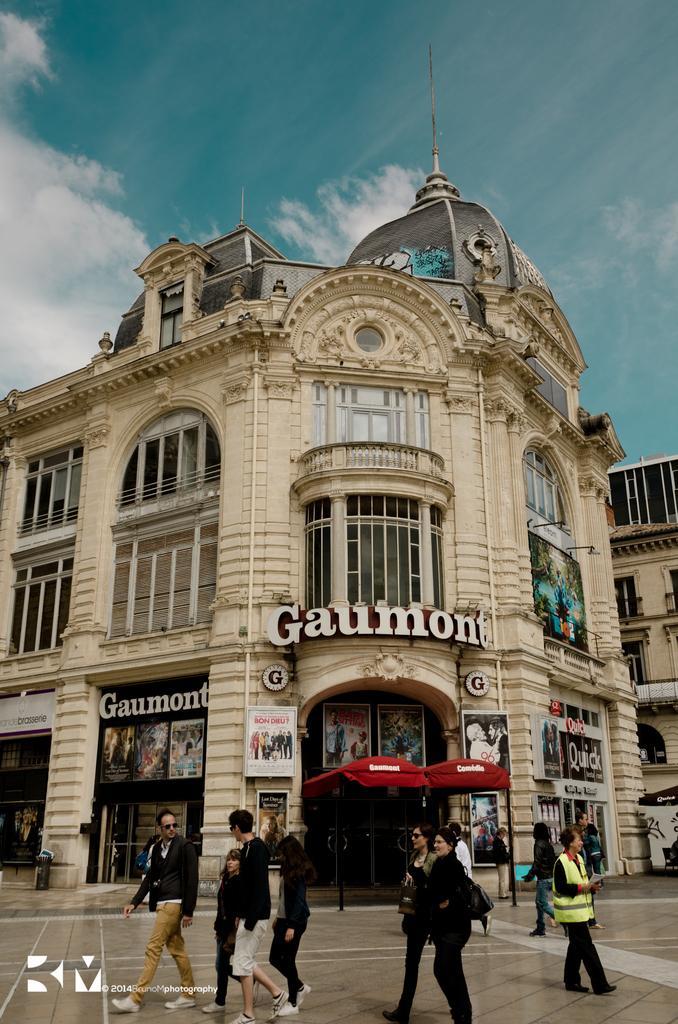Describe this image in one or two sentences. In this image I can see a building I can see its doors, windows, a title and some banners or boards with some text. At the bottom of the image I can see some people standing and walking on the road. At the top of the image I can see the sky. 